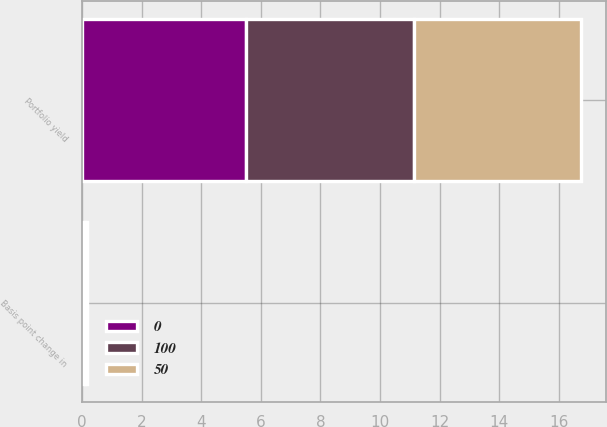Convert chart to OTSL. <chart><loc_0><loc_0><loc_500><loc_500><stacked_bar_chart><ecel><fcel>Portfolio yield<fcel>Basis point change in<nl><fcel>0<fcel>5.52<fcel>0.11<nl><fcel>50<fcel>5.58<fcel>0.05<nl><fcel>100<fcel>5.63<fcel>0<nl></chart> 